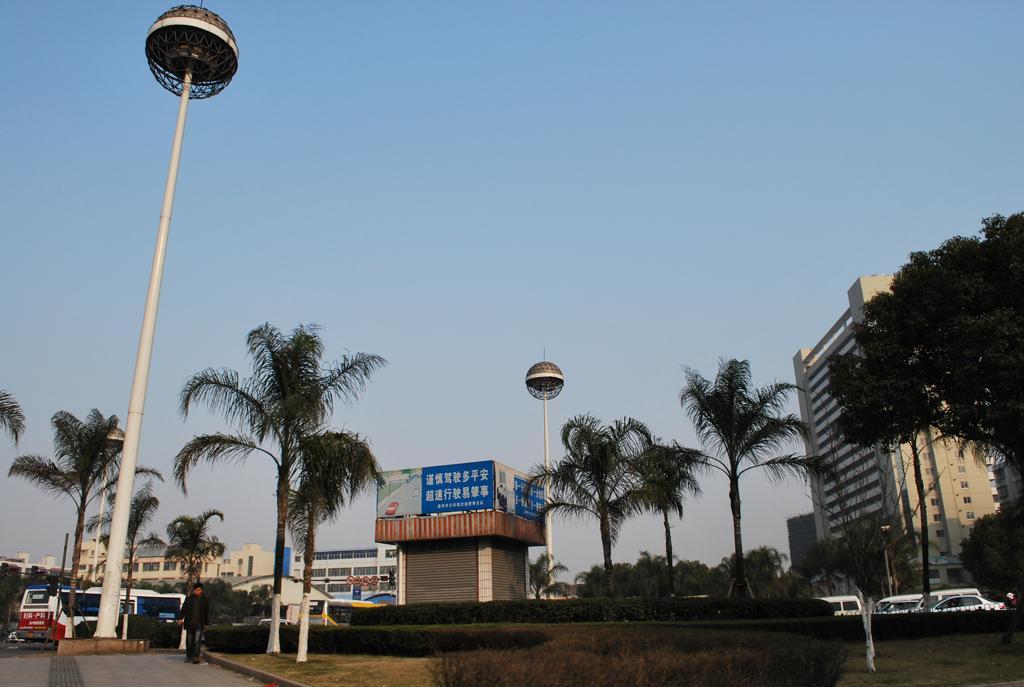In one or two sentences, can you explain what this image depicts? In this picture we can see a person walking on a footpath, trees, buildings, shutters, banners, vehicles, poles, plants and in the background we can see the sky. 